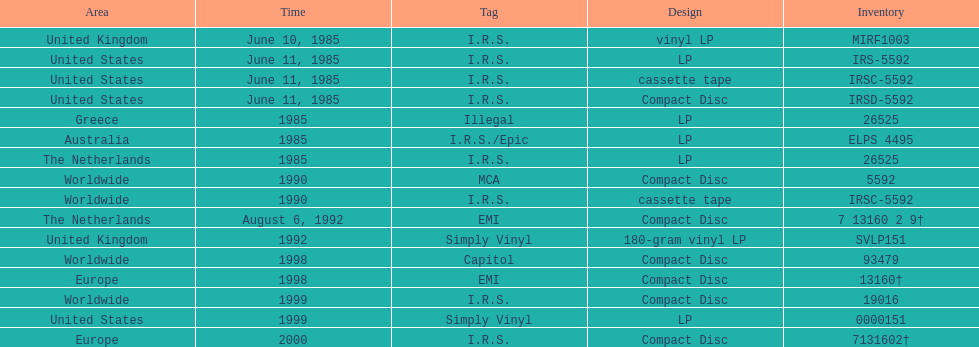Which country or region had the most releases? Worldwide. 